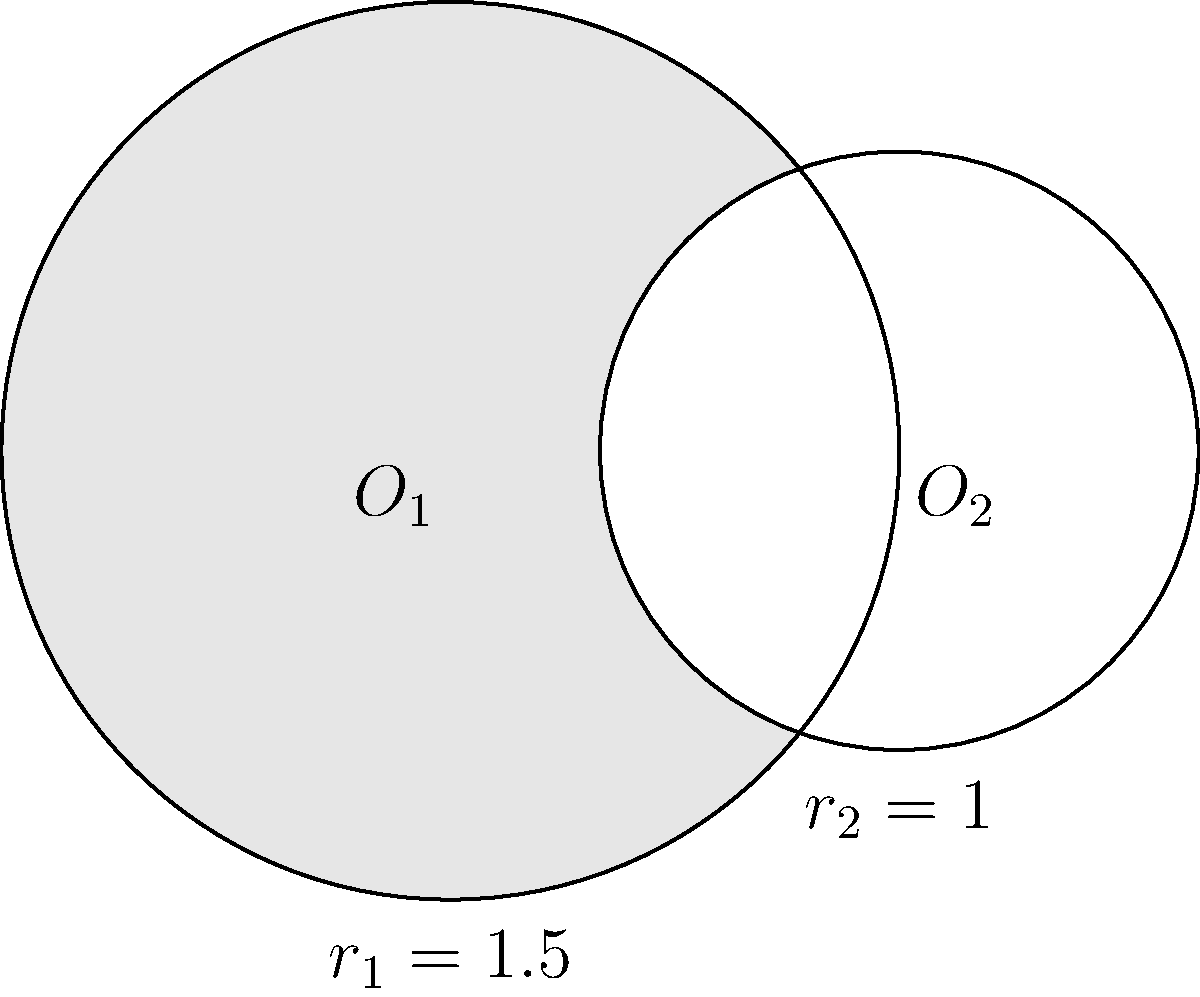In a digital marketing campaign for a family tree platform, you're creating a visually appealing infographic. The design involves two overlapping circles representing different user demographics. The larger circle (centered at $O_1$) has a radius of 1.5 units, while the smaller circle (centered at $O_2$) has a radius of 1 unit. The centers of the circles are 1.5 units apart. Calculate the area of the shaded region formed by the intersection of these two circles. Round your answer to two decimal places. Let's approach this step-by-step:

1) First, we need to find the angle $\theta$ at the center of each circle formed by the line joining the centers and the line to an intersection point.

   For circle 1: $\cos\theta_1 = \frac{1.5^2 + 1.5^2 - 1^2}{2(1.5)(1.5)} = \frac{3.5}{4.5} = 0.7778$
   $\theta_1 = \arccos(0.7778) = 0.6847$ radians

   For circle 2: $\cos\theta_2 = \frac{1.5^2 + 1^2 - 1.5^2}{2(1.5)(1)} = \frac{1}{3} = 0.3333$
   $\theta_2 = \arccos(0.3333) = 1.2310$ radians

2) The area of a sector is given by $\frac{1}{2}r^2\theta$, where $r$ is the radius and $\theta$ is the angle in radians.

   Area of sector in circle 1: $A_1 = \frac{1}{2}(1.5^2)(0.6847) = 0.7704$
   Area of sector in circle 2: $A_2 = \frac{1}{2}(1^2)(1.2310) = 0.6155$

3) The area of the triangle formed by the center of each circle and the intersection points is:
   $A_t = \frac{1}{2}(1.5)(1.5)\sin(0.6847) = 0.5625$

4) The shaded area is the sum of the two sectors minus twice the area of the triangle:
   $A_{shaded} = A_1 + A_2 - 2A_t = 0.7704 + 0.6155 - 2(0.5625) = 0.2609$

5) Rounding to two decimal places: 0.26 square units.
Answer: 0.26 square units 